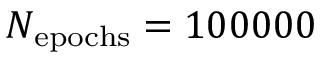Convert formula to latex. <formula><loc_0><loc_0><loc_500><loc_500>N _ { e p o c h s } = 1 0 0 0 0 0</formula> 